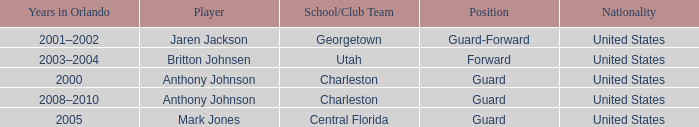Write the full table. {'header': ['Years in Orlando', 'Player', 'School/Club Team', 'Position', 'Nationality'], 'rows': [['2001–2002', 'Jaren Jackson', 'Georgetown', 'Guard-Forward', 'United States'], ['2003–2004', 'Britton Johnsen', 'Utah', 'Forward', 'United States'], ['2000', 'Anthony Johnson', 'Charleston', 'Guard', 'United States'], ['2008–2010', 'Anthony Johnson', 'Charleston', 'Guard', 'United States'], ['2005', 'Mark Jones', 'Central Florida', 'Guard', 'United States']]} What was the place of the participant, britton johnsen? Forward. 